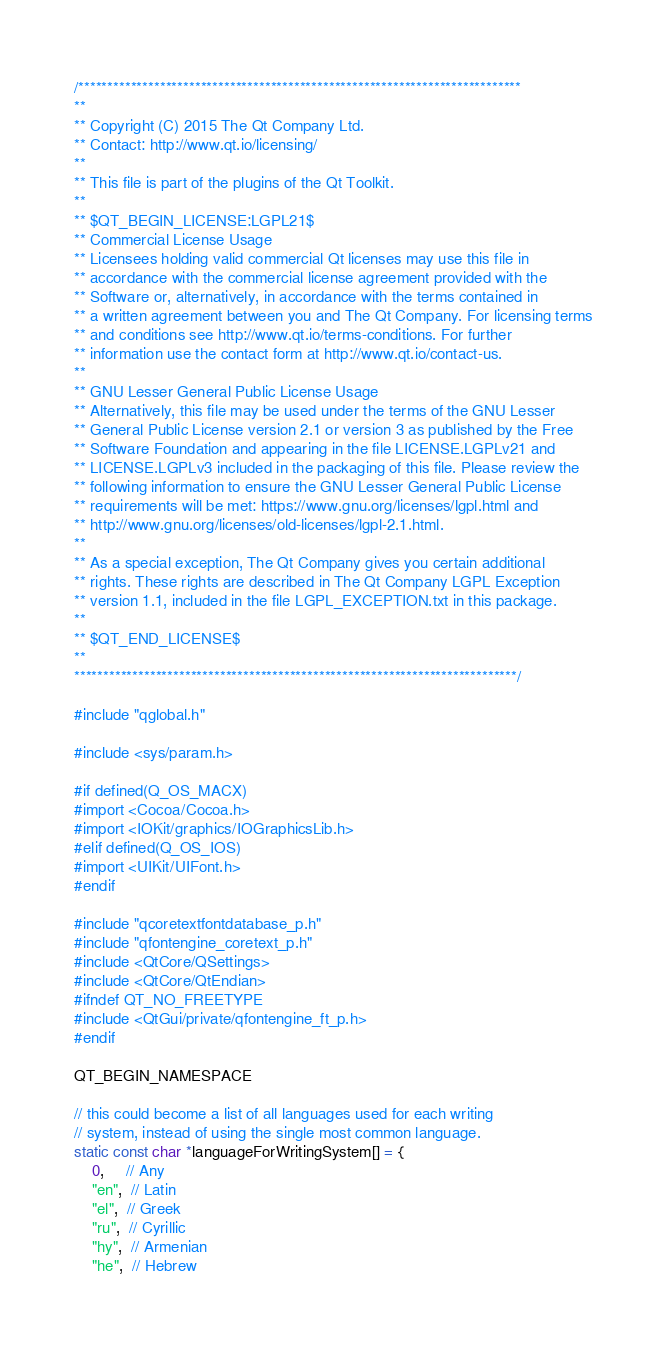<code> <loc_0><loc_0><loc_500><loc_500><_ObjectiveC_>/****************************************************************************
**
** Copyright (C) 2015 The Qt Company Ltd.
** Contact: http://www.qt.io/licensing/
**
** This file is part of the plugins of the Qt Toolkit.
**
** $QT_BEGIN_LICENSE:LGPL21$
** Commercial License Usage
** Licensees holding valid commercial Qt licenses may use this file in
** accordance with the commercial license agreement provided with the
** Software or, alternatively, in accordance with the terms contained in
** a written agreement between you and The Qt Company. For licensing terms
** and conditions see http://www.qt.io/terms-conditions. For further
** information use the contact form at http://www.qt.io/contact-us.
**
** GNU Lesser General Public License Usage
** Alternatively, this file may be used under the terms of the GNU Lesser
** General Public License version 2.1 or version 3 as published by the Free
** Software Foundation and appearing in the file LICENSE.LGPLv21 and
** LICENSE.LGPLv3 included in the packaging of this file. Please review the
** following information to ensure the GNU Lesser General Public License
** requirements will be met: https://www.gnu.org/licenses/lgpl.html and
** http://www.gnu.org/licenses/old-licenses/lgpl-2.1.html.
**
** As a special exception, The Qt Company gives you certain additional
** rights. These rights are described in The Qt Company LGPL Exception
** version 1.1, included in the file LGPL_EXCEPTION.txt in this package.
**
** $QT_END_LICENSE$
**
****************************************************************************/

#include "qglobal.h"

#include <sys/param.h>

#if defined(Q_OS_MACX)
#import <Cocoa/Cocoa.h>
#import <IOKit/graphics/IOGraphicsLib.h>
#elif defined(Q_OS_IOS)
#import <UIKit/UIFont.h>
#endif

#include "qcoretextfontdatabase_p.h"
#include "qfontengine_coretext_p.h"
#include <QtCore/QSettings>
#include <QtCore/QtEndian>
#ifndef QT_NO_FREETYPE
#include <QtGui/private/qfontengine_ft_p.h>
#endif

QT_BEGIN_NAMESPACE

// this could become a list of all languages used for each writing
// system, instead of using the single most common language.
static const char *languageForWritingSystem[] = {
    0,     // Any
    "en",  // Latin
    "el",  // Greek
    "ru",  // Cyrillic
    "hy",  // Armenian
    "he",  // Hebrew</code> 